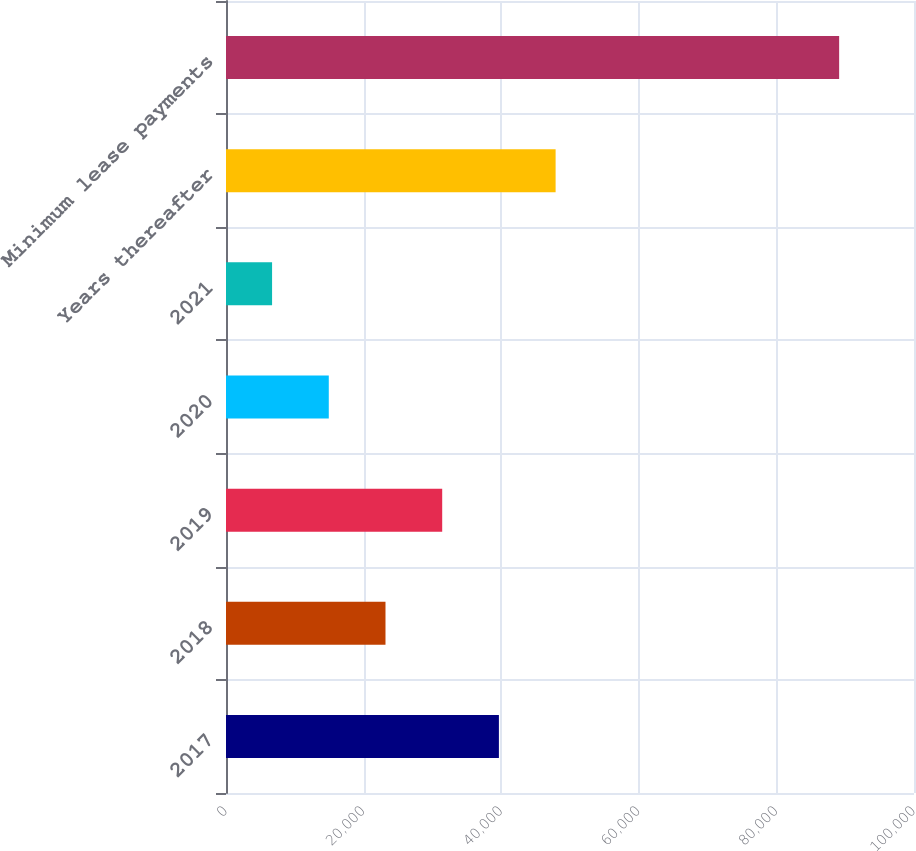<chart> <loc_0><loc_0><loc_500><loc_500><bar_chart><fcel>2017<fcel>2018<fcel>2019<fcel>2020<fcel>2021<fcel>Years thereafter<fcel>Minimum lease payments<nl><fcel>39666.2<fcel>23181.6<fcel>31423.9<fcel>14939.3<fcel>6697<fcel>47908.5<fcel>89120<nl></chart> 